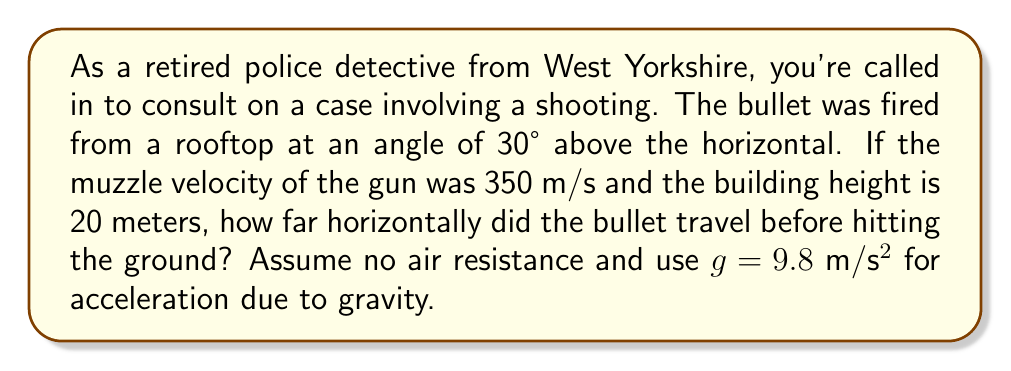Give your solution to this math problem. Let's approach this step-by-step using trigonometric functions and projectile motion equations:

1) First, we need to break down the initial velocity into its horizontal and vertical components:

   $v_x = v \cos \theta = 350 \cos 30° = 350 \cdot \frac{\sqrt{3}}{2} \approx 303.11$ m/s
   $v_y = v \sin \theta = 350 \sin 30° = 350 \cdot \frac{1}{2} = 175$ m/s

2) The horizontal distance ($x$) is related to the horizontal velocity ($v_x$) and time ($t$):

   $x = v_x t$

3) To find $t$, we can use the vertical motion equation:

   $y = v_y t - \frac{1}{2}gt^2$

   Where $y$ is the vertical displacement (-20 m, as the bullet moves down 20 m)

4) Substituting our values:

   $-20 = 175t - \frac{1}{2}(9.8)t^2$

5) Rearranging:

   $4.9t^2 - 175t - 20 = 0$

6) This is a quadratic equation. We can solve it using the quadratic formula:

   $t = \frac{-b \pm \sqrt{b^2 - 4ac}}{2a}$

   Where $a = 4.9$, $b = -175$, and $c = -20$

7) Solving:

   $t = \frac{175 \pm \sqrt{175^2 - 4(4.9)(-20)}}{2(4.9)} \approx 3.64$ s

   (We take the positive root as time can't be negative)

8) Now we can find the horizontal distance:

   $x = v_x t = 303.11 \cdot 3.64 \approx 1103.32$ m

Therefore, the bullet traveled approximately 1103.32 meters horizontally before hitting the ground.
Answer: The bullet traveled approximately 1103.32 meters horizontally before hitting the ground. 